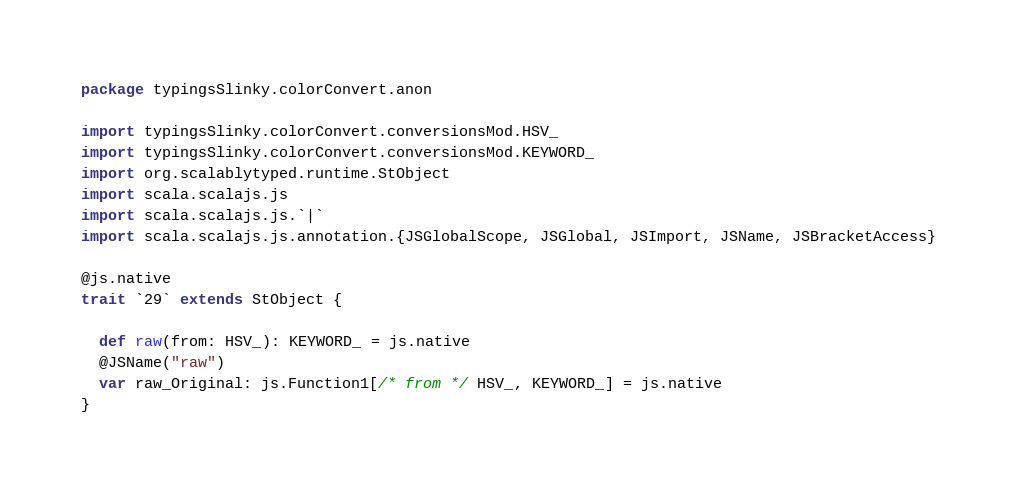Convert code to text. <code><loc_0><loc_0><loc_500><loc_500><_Scala_>package typingsSlinky.colorConvert.anon

import typingsSlinky.colorConvert.conversionsMod.HSV_
import typingsSlinky.colorConvert.conversionsMod.KEYWORD_
import org.scalablytyped.runtime.StObject
import scala.scalajs.js
import scala.scalajs.js.`|`
import scala.scalajs.js.annotation.{JSGlobalScope, JSGlobal, JSImport, JSName, JSBracketAccess}

@js.native
trait `29` extends StObject {
  
  def raw(from: HSV_): KEYWORD_ = js.native
  @JSName("raw")
  var raw_Original: js.Function1[/* from */ HSV_, KEYWORD_] = js.native
}
</code> 